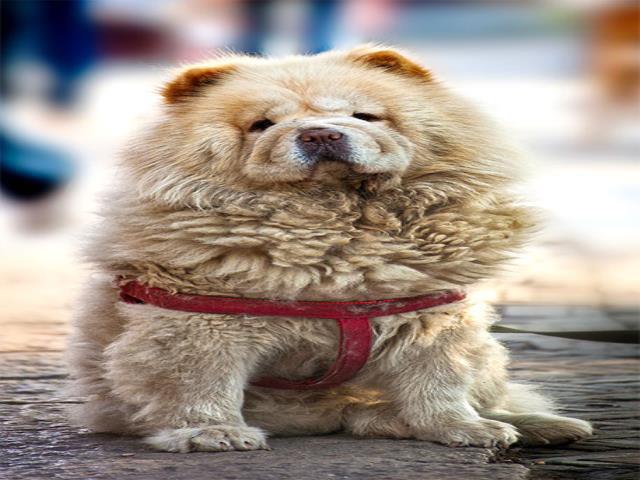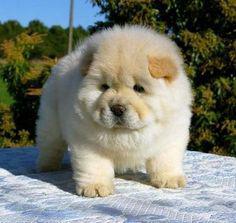The first image is the image on the left, the second image is the image on the right. Analyze the images presented: Is the assertion "There are three dogs" valid? Answer yes or no. No. 